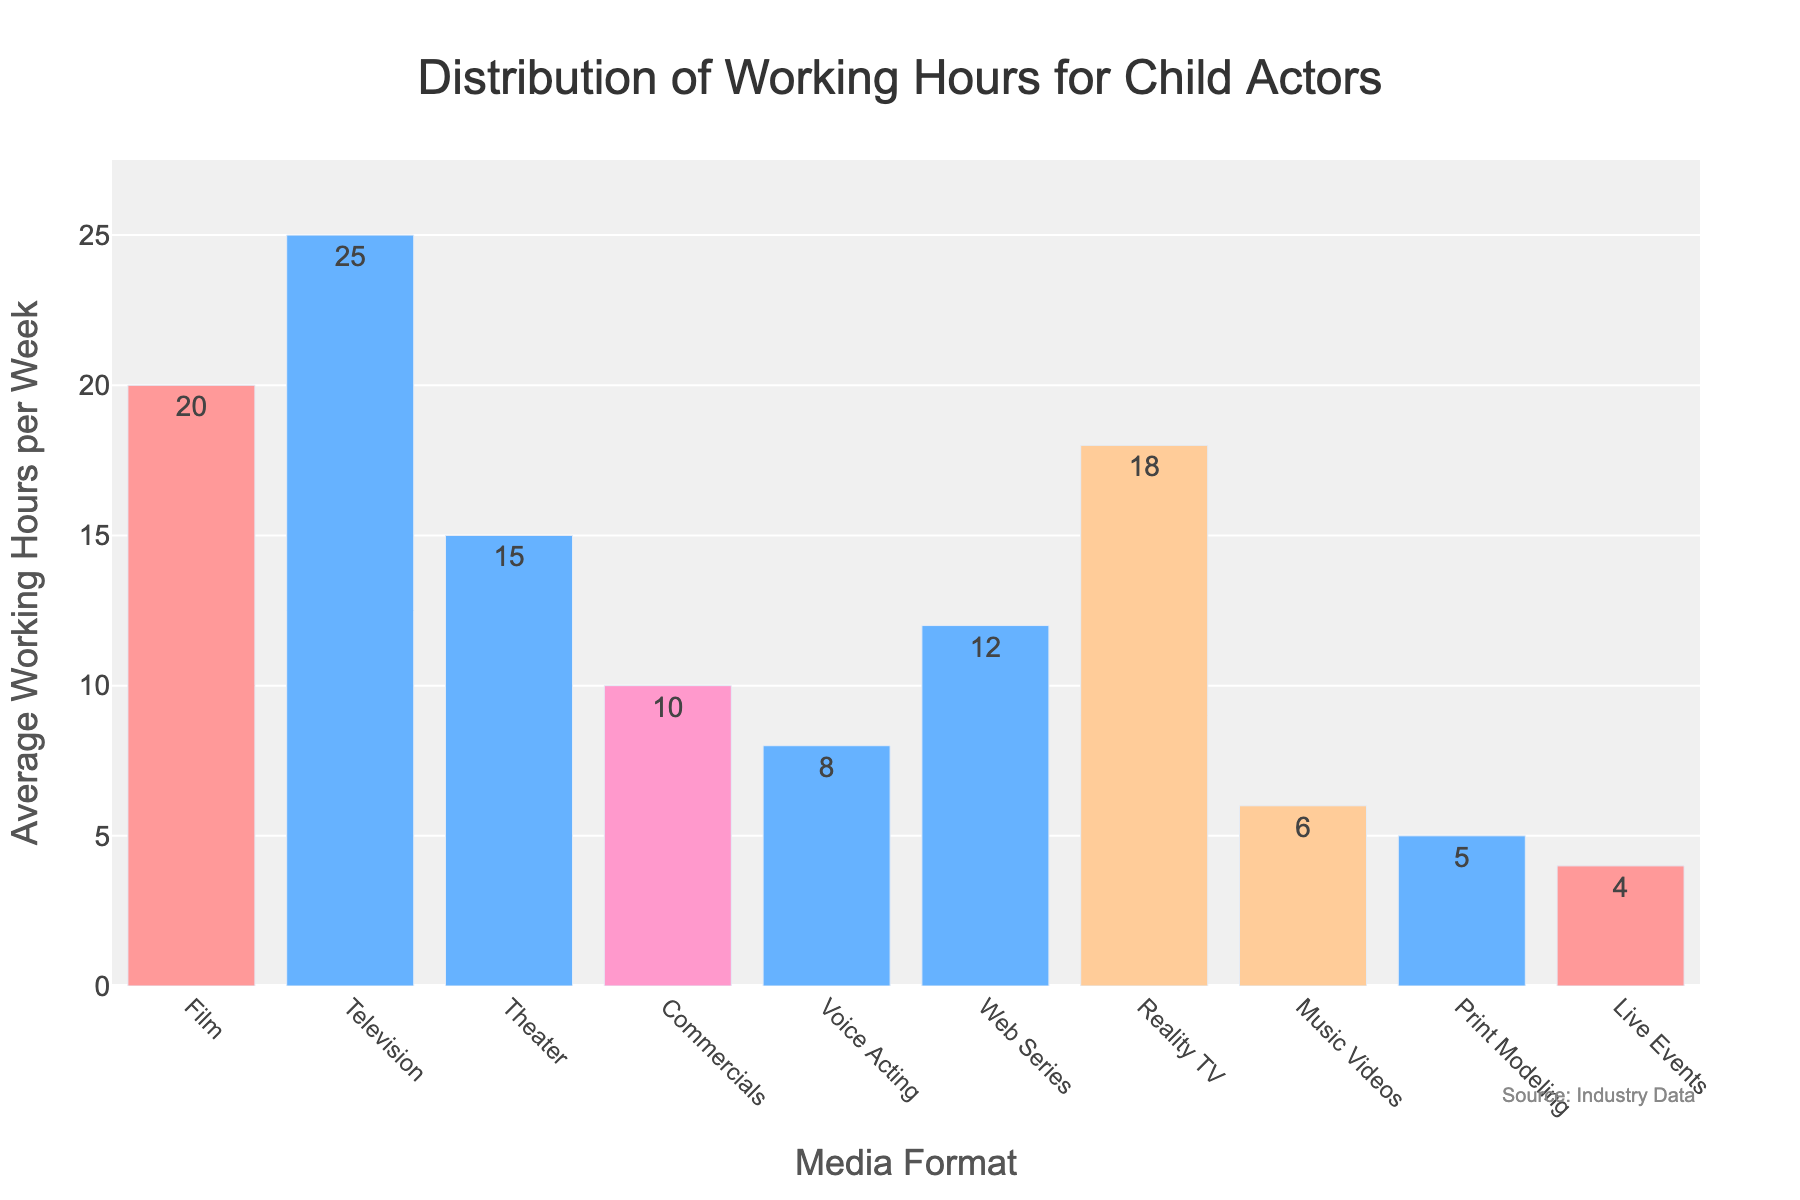What media format requires the most average working hours per week? First, identify the bar with the greatest height. The 'Television' format has the tallest bar, representing 25 hours per week, which is the highest among all media formats.
Answer: Television Which media format has the least average working hours per week? Look for the shortest bar in the chart. The 'Live Events' format has the shortest bar, representing 4 hours per week.
Answer: Live Events How many more hours per week do child actors work in film compared to commercials? From the chart, film has 20 hours per week and commercials have 10 hours per week. Calculate the difference: 20 - 10 = 10 hours.
Answer: 10 hours What is the cumulative average working hours per week for child actors in Voice Acting, Web Series, and Reality TV? From the chart, voice acting has 8 hours, web series has 12 hours, and reality TV has 18 hours. Add these: 8 + 12 + 18 = 38 hours.
Answer: 38 hours Is the average working hours per week for Theater greater than or less than Reality TV? Compare the heights of the bars for 'Theater' and 'Reality TV'. Theater has 15 hours and Reality TV has 18 hours. 15 is less than 18.
Answer: Less than Which three media formats have the highest average working hours per week? Identify the top three tallest bars. They are for Television (25 hours), Film (20 hours), and Reality TV (18 hours).
Answer: Television, Film, Reality TV Are the average working hours for Music Videos greater than for Print Modeling? Compare the 'Music Videos' bar (6 hours) with the 'Print Modeling' bar (5 hours). 6 is greater than 5.
Answer: Greater than How do the average working hours in Theater compare to those in Web Series? Identify the bars for Theater (15 hours) and Web Series (12 hours). Theater's bar is taller, indicating 15 is greater than 12.
Answer: Greater than What is the combined average working hours per week for Film and Television? Add the average working hours for Film (20 hours) and Television (25 hours): 20 + 25 = 45 hours.
Answer: 45 hours 